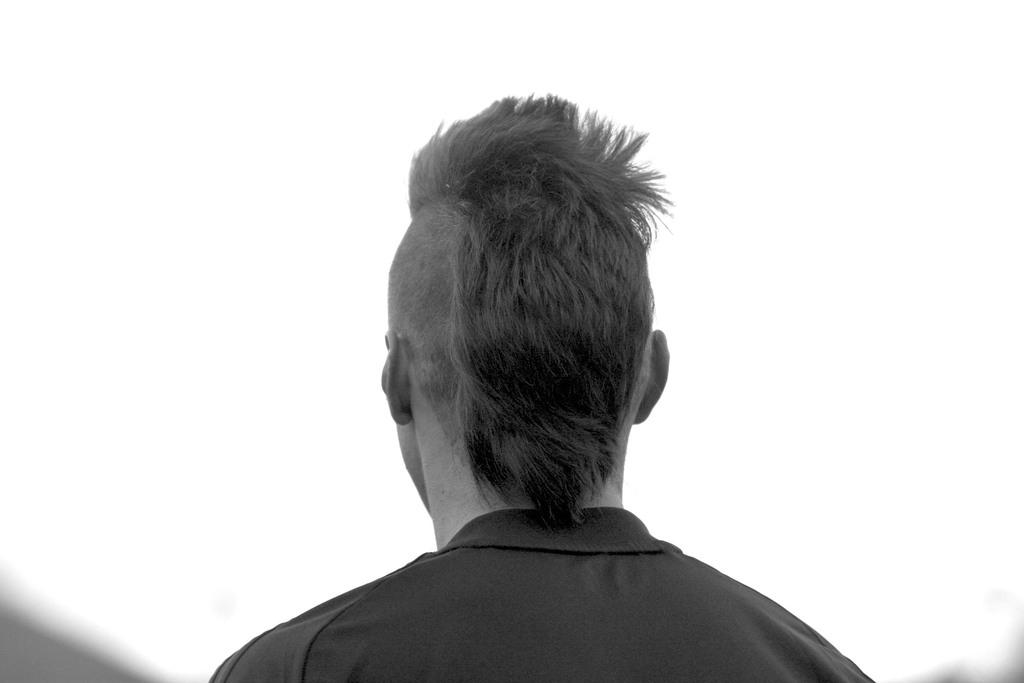Who or what is present in the image? There is a person in the image. What can be seen in the background of the image? The sky is visible at the top of the image. What time of day is the person offering mailbox services in the image? There is no indication of time or mailbox services in the image; it only shows a person and the sky. 